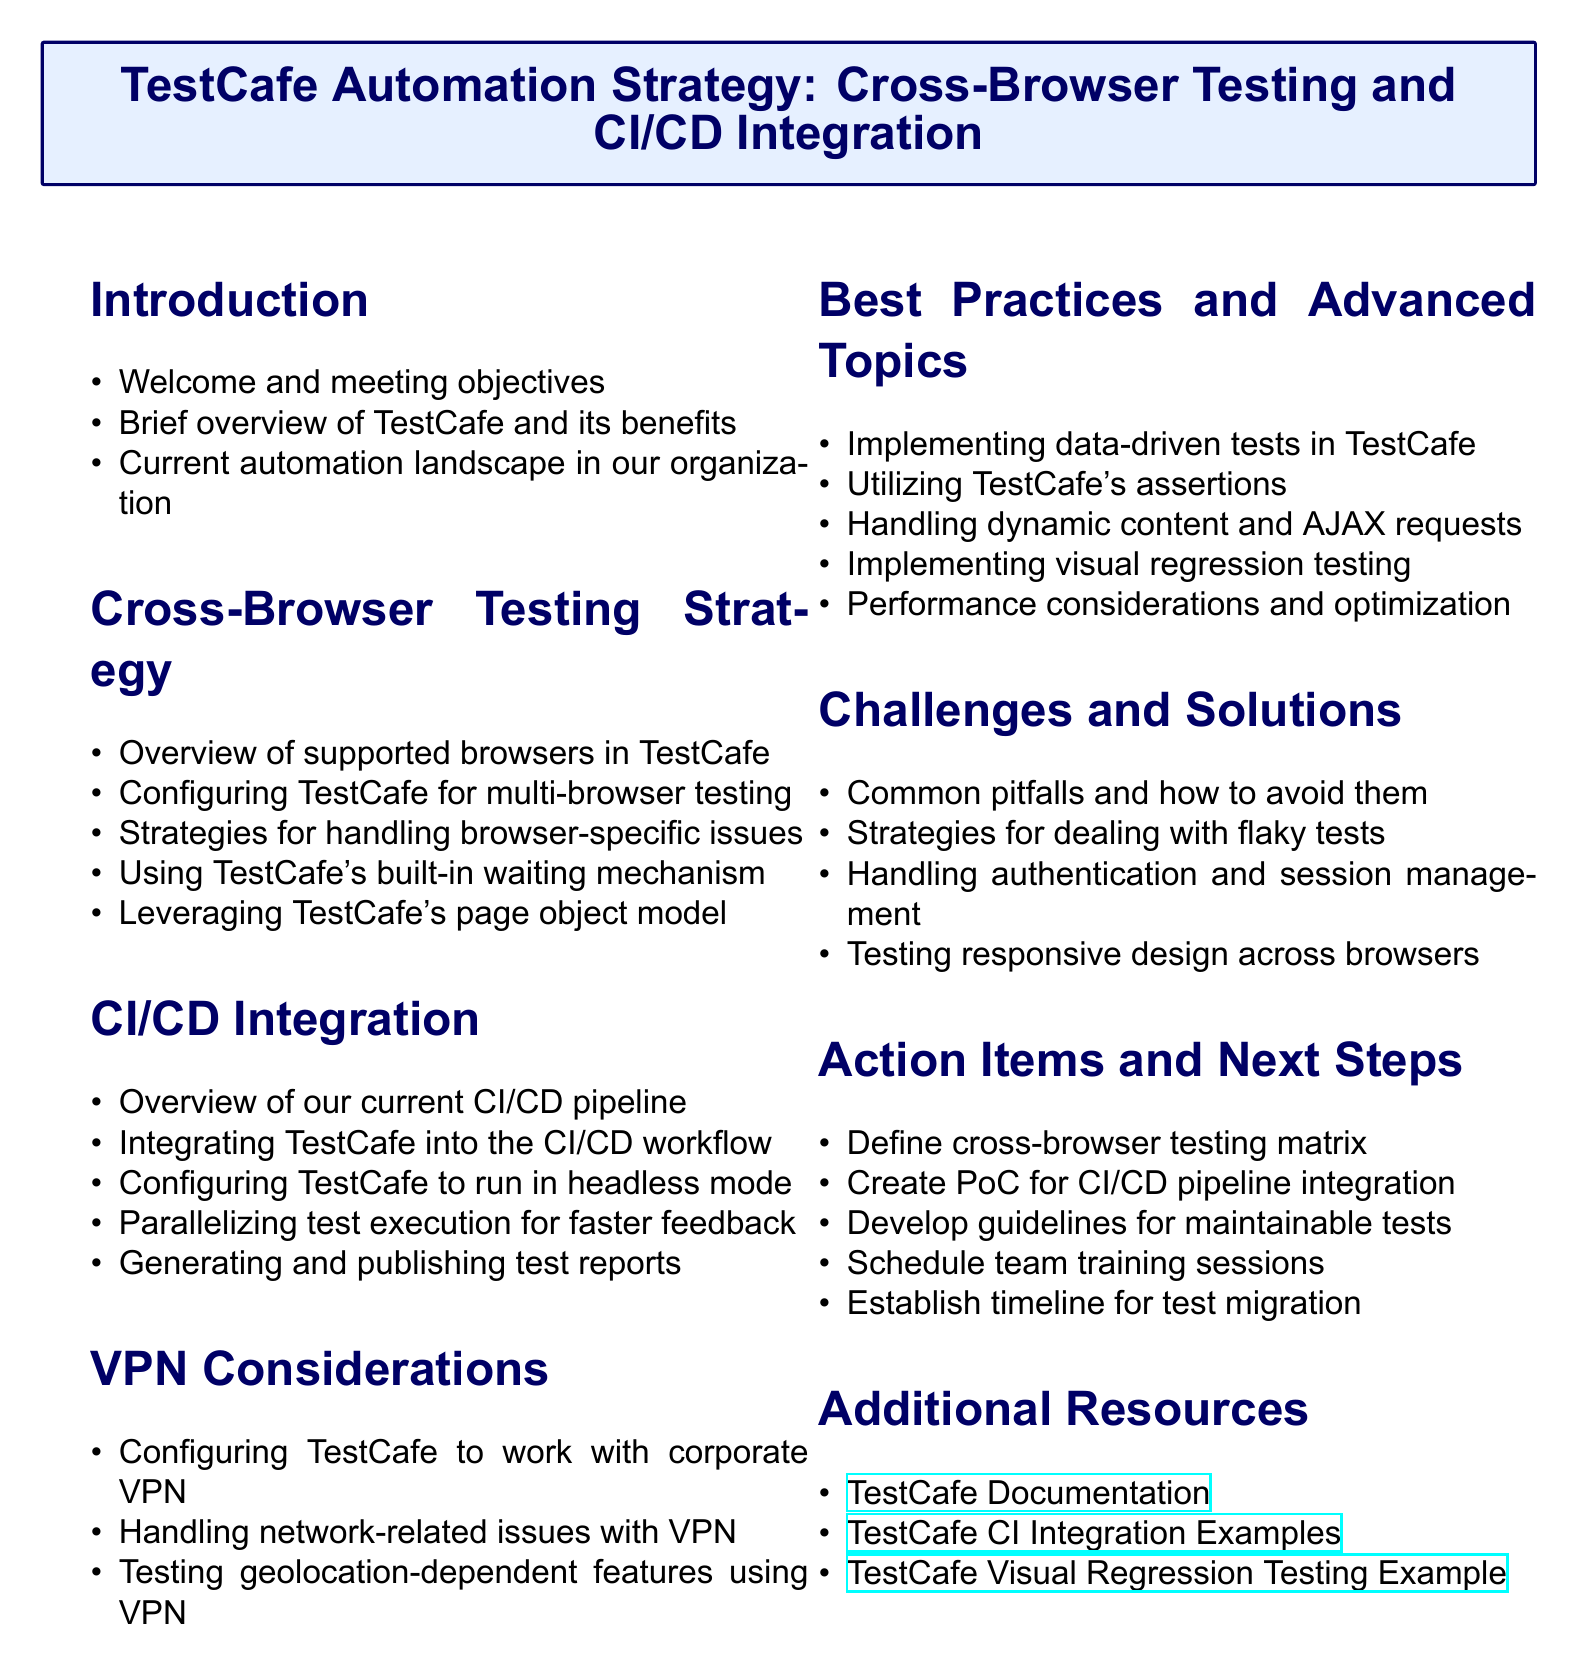What is the title of the meeting? The title of the meeting is presented at the top of the agenda document.
Answer: TestCafe Automation Strategy: Cross-Browser Testing and CI/CD Integration Which browsers are supported by TestCafe? The section on Cross-Browser Testing Strategy provides the list of supported browsers.
Answer: Chrome, Firefox, Safari, Edge What is the first item in the CI/CD Integration section? The first item listed under the CI/CD Integration section is crucial for understanding the current state of integration.
Answer: Overview of our current CI/CD pipeline What is the focus of the VPN Considerations section? This section discusses specific factors related to using TestCafe with a corporate VPN.
Answer: Configuring TestCafe to work with our corporate VPN How many action items are listed in the Action Items and Next Steps section? Counting the items in the Action Items and Next Steps section gives insight into the meeting's outcome.
Answer: Five What strategy is mentioned for handling dynamic content? The document includes strategies for specific challenges; this one relates to dynamic content.
Answer: Handling dynamic content and AJAX requests What type of testing does the Best Practices section mention implementing? The document suggests advanced techniques within TestCafe; this example is related to testing.
Answer: Visual regression testing What is one common pitfall in TestCafe automation? The Challenges and Solutions section addresses potential issues in automation practice.
Answer: Common pitfalls in TestCafe automation and how to avoid them 